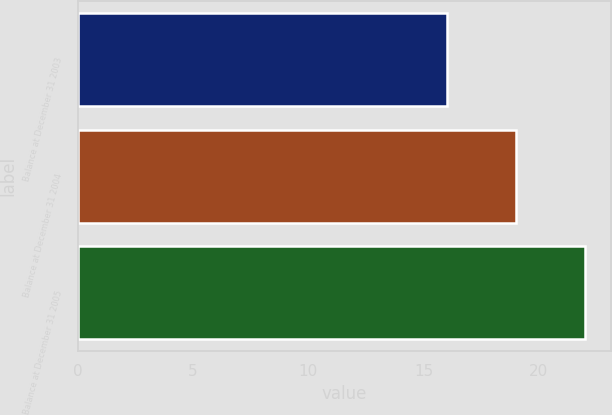Convert chart to OTSL. <chart><loc_0><loc_0><loc_500><loc_500><bar_chart><fcel>Balance at December 31 2003<fcel>Balance at December 31 2004<fcel>Balance at December 31 2005<nl><fcel>16<fcel>19<fcel>22<nl></chart> 